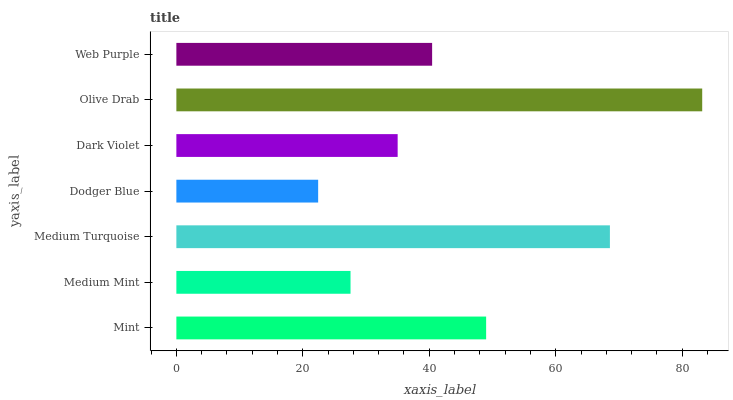Is Dodger Blue the minimum?
Answer yes or no. Yes. Is Olive Drab the maximum?
Answer yes or no. Yes. Is Medium Mint the minimum?
Answer yes or no. No. Is Medium Mint the maximum?
Answer yes or no. No. Is Mint greater than Medium Mint?
Answer yes or no. Yes. Is Medium Mint less than Mint?
Answer yes or no. Yes. Is Medium Mint greater than Mint?
Answer yes or no. No. Is Mint less than Medium Mint?
Answer yes or no. No. Is Web Purple the high median?
Answer yes or no. Yes. Is Web Purple the low median?
Answer yes or no. Yes. Is Medium Turquoise the high median?
Answer yes or no. No. Is Dodger Blue the low median?
Answer yes or no. No. 